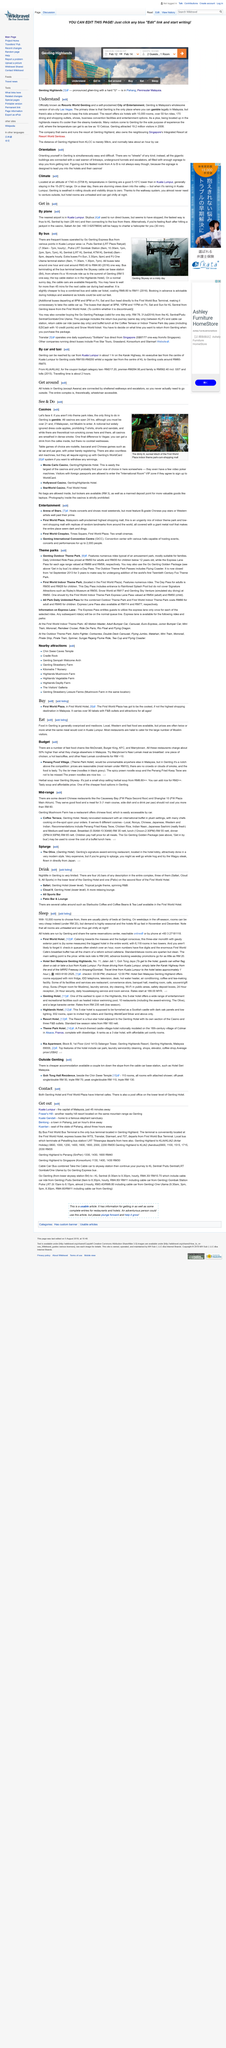Draw attention to some important aspects in this diagram. There are 10,000 rooms available for guests to choose from at Genting. The First World Bus Terminal is located within Genting Highland. Specifically, it is situated within the First World Hotel. Genting is pronounced with a hard G, not a soft one. The Genting Highlands is a destination located in Pahang, Peninsular Malaysia. In 2008, it attracted a total of 19.2 million visitors, making it a popular tourist attraction. The article discusses the biggest hotel in the entire world, which has 6,118 rooms in two towers. 